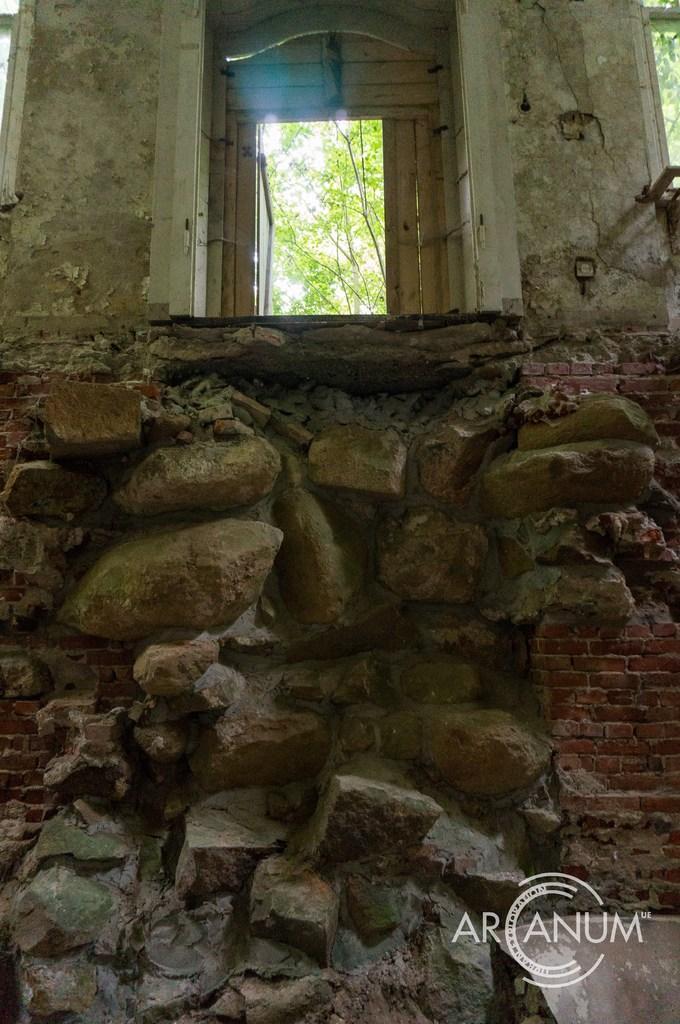Please provide a concise description of this image. This image is taken in outdoors. In the bottom of the image there is a wall with stones and bricks. At the top of the image there is an arch with door and back of it there are many trees. 